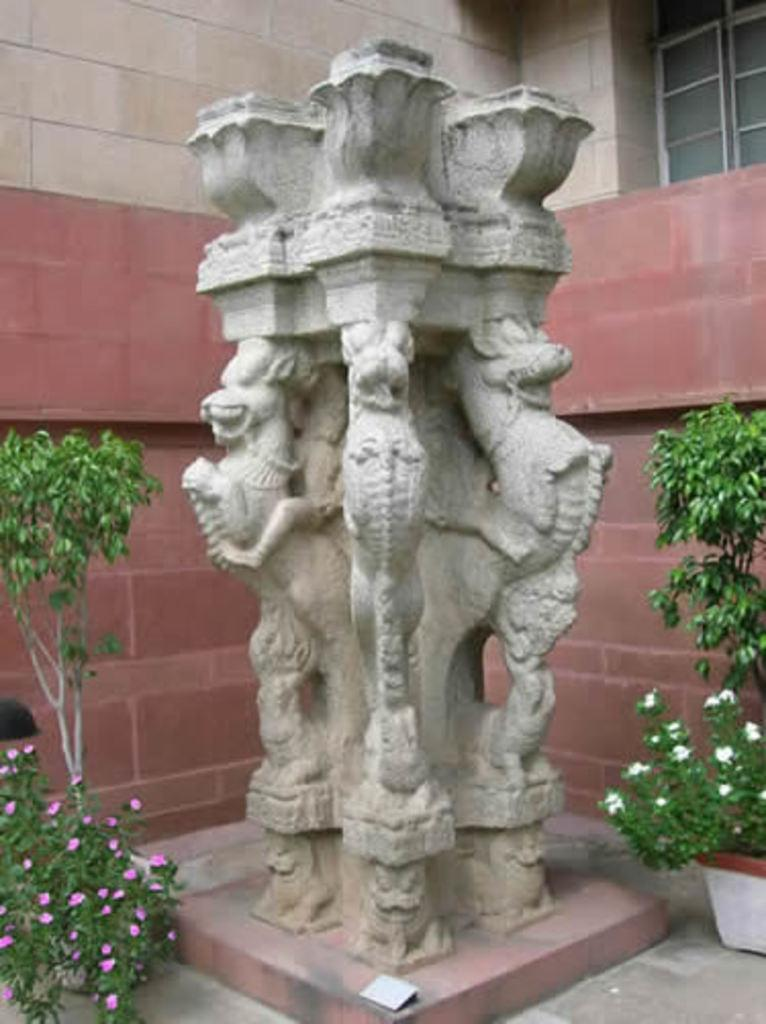What is the main subject of the image? There is a sculpture in the image. What other elements can be seen in the image besides the sculpture? There are plants with flowers and a building with a window in the image. What type of cheese can be seen in the image? There is no cheese present in the image. Are there any stockings visible in the image? There are no stockings present in the image. 